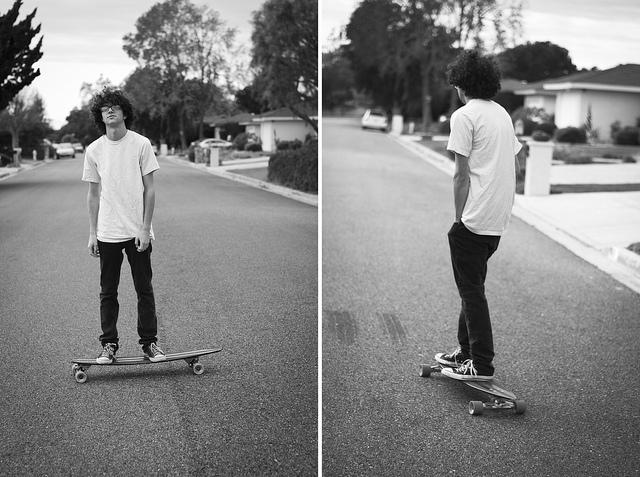What kind of board is the man riding?
Give a very brief answer. Skateboard. Are skateboards safe?
Short answer required. Yes. What is the type of transportation being used?
Answer briefly. Skateboard. 